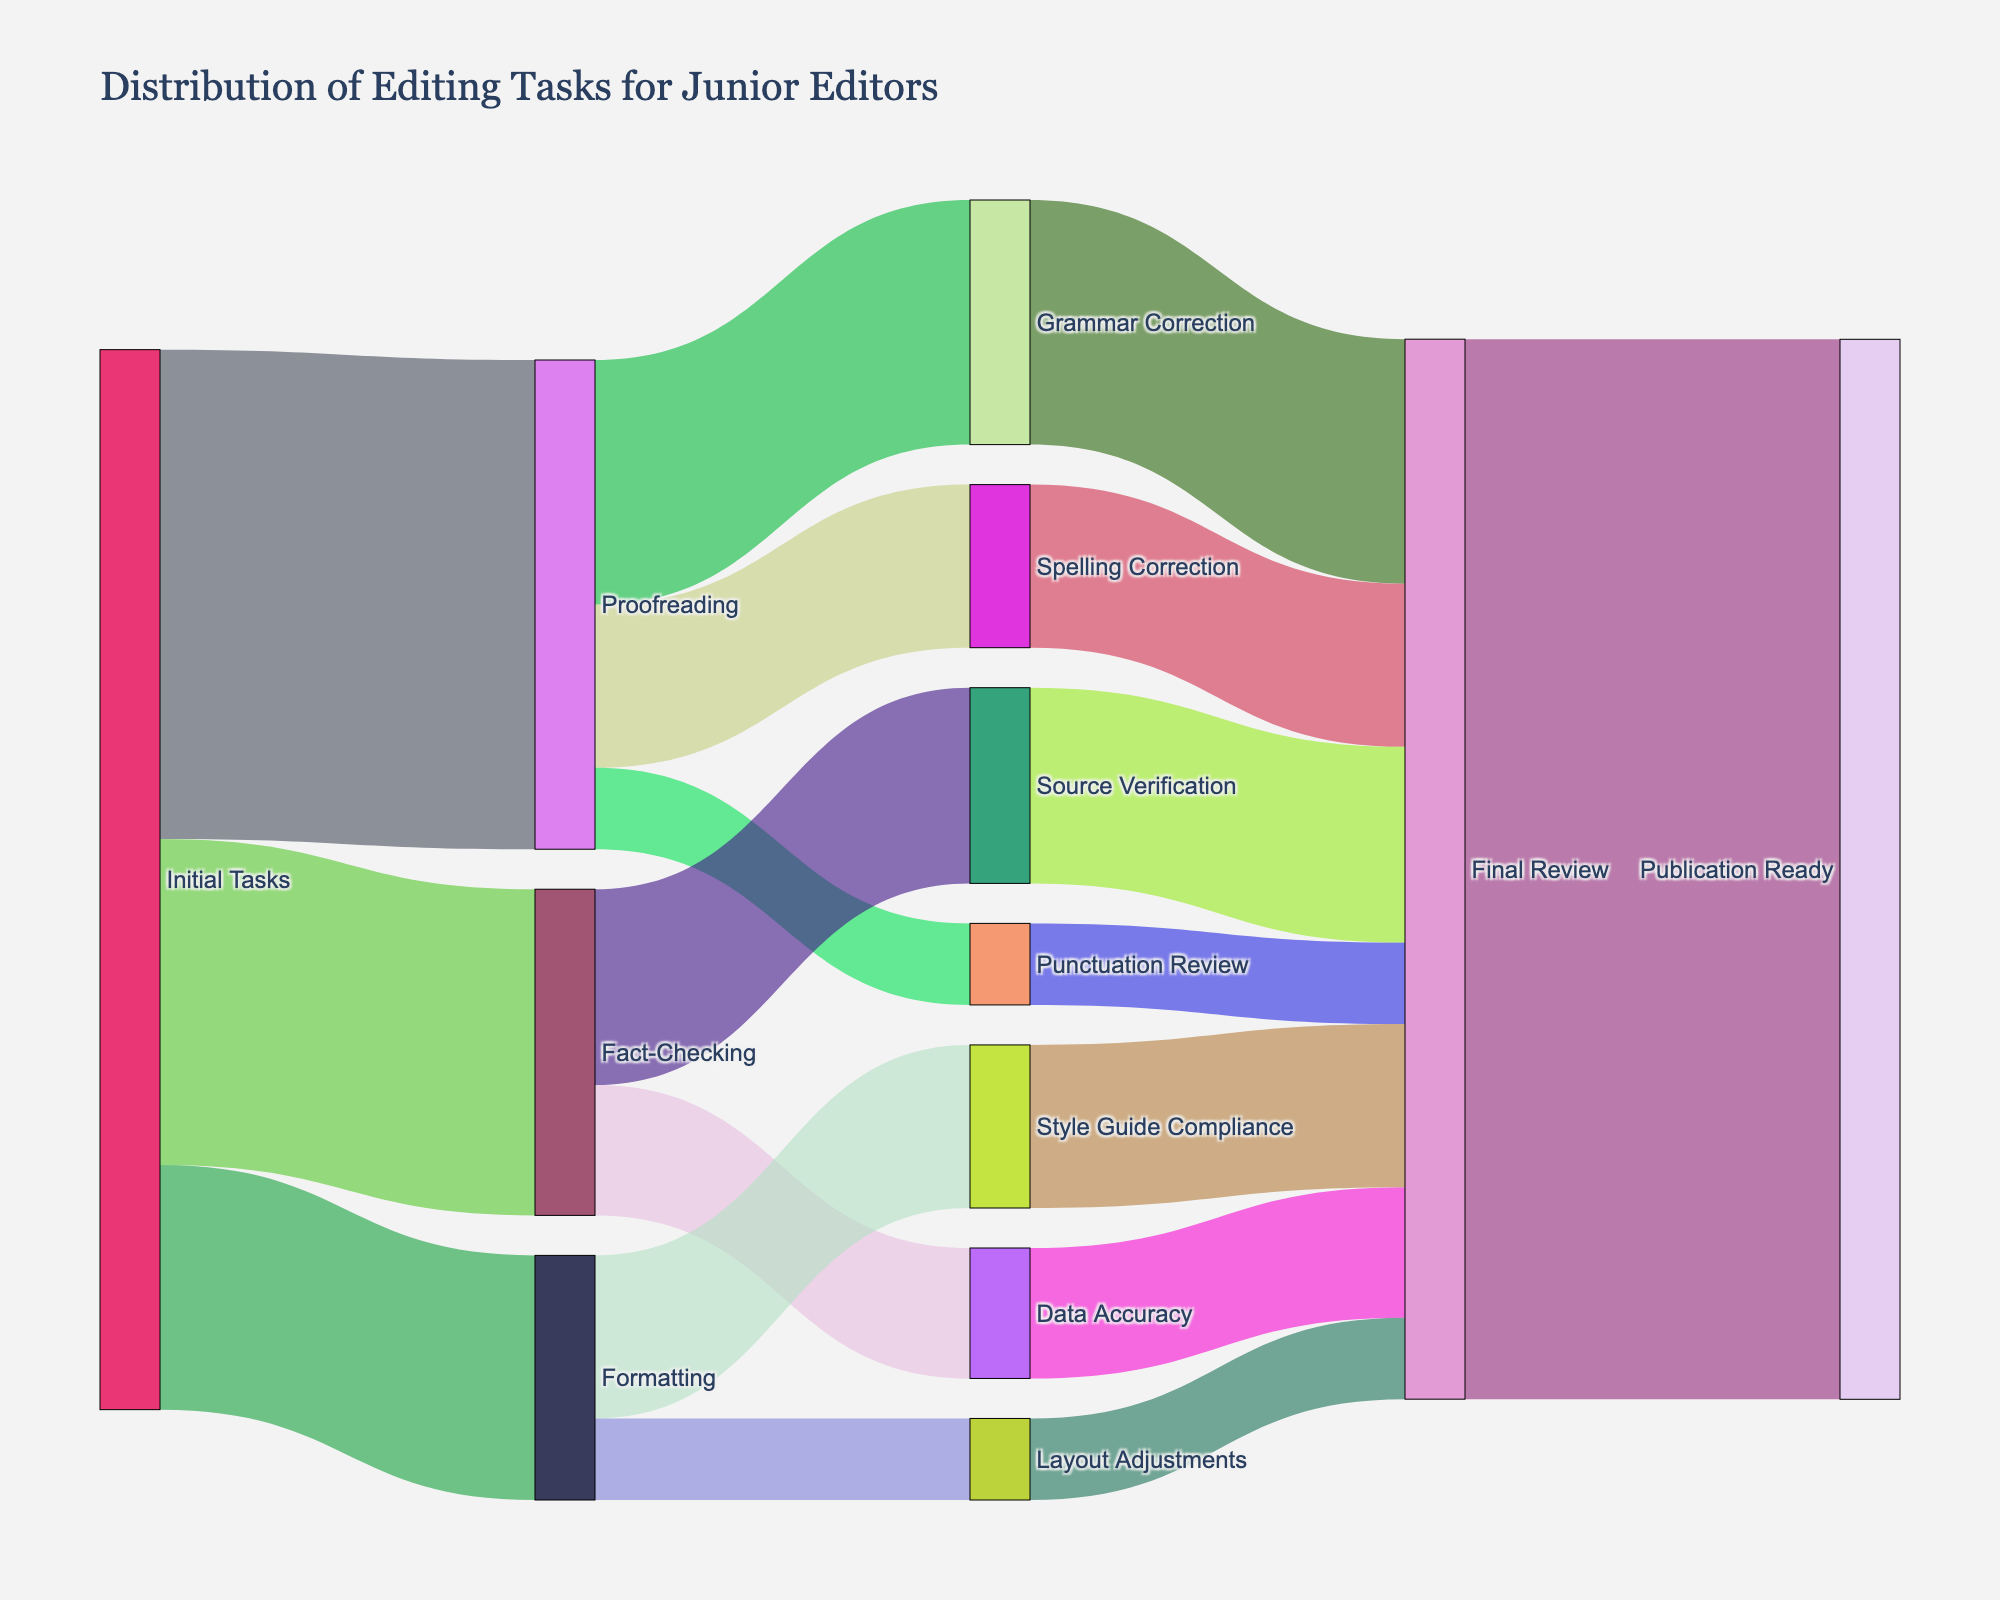What is the title of the Sankey diagram? The title can be found at the top of the diagram. It provides an immediate summary of what the diagram is illustrating.
Answer: Distribution of Editing Tasks for Junior Editors How many different types of initial tasks are there? Count the distinct types of tasks originating from the "Initial Tasks" node. These tasks are Proofreading, Fact-Checking, and Formatting.
Answer: 3 Which task shows the highest number of connections originating from Proofreading? Follow the links starting from Proofreading. Count their occurrences and identify the one with the largest value (Grammar Correction: 15, Spelling Correction: 10, Punctuation Review: 5).
Answer: Grammar Correction Which two subtasks of Fact-Checking have been performed? Identify the tasks directly connected to Fact-Checking (Source Verification and Data Accuracy). The subtasks are the nodes linking from Fact-Checking.
Answer: Source Verification and Data Accuracy What is the final destination for all the editing tasks? Trace the paths of all the flows until they reach the final node, which in this case is "Publication Ready."
Answer: Publication Ready How many tasks go to the Final Review node? Sum all the values of tasks flowing into the "Final Review" node. (e.g., Grammar Correction: 15, Spelling Correction: 10, Punctuation Review: 5, Source Verification: 12, Data Accuracy: 8, Style Guide Compliance: 10, Layout Adjustments: 5).
Answer: 65 What is the total number of tasks that originated from Fact-Checking? Add up the values for all connections originating from "Fact-Checking" (Source Verification: 12 and Data Accuracy: 8).
Answer: 20 How does the number of tasks involved in Grammar Correction compare to Spelling Correction? Compare the values of tasks from Proofreading that flow into Grammar Correction and Spelling Correction nodes. Grammar Correction has 15, while Spelling Correction has 10.
Answer: Grammar Correction has more Which process ensures there are most tasks in the "Final Review" stage? Identify the process that sends the highest number of tasks to the "Final Review" node. Trace the largest value originating to Final Review. (Grammar Correction: 15).
Answer: Grammar Correction What proportion of initial Proofreading tasks resulted in Grammar Correction? Divide the number of tasks from Proofreading to Grammar Correction by the total number of Proofreading tasks (Grammar Correction: 15 / Proofreading: 15 + 10 + 5 = 30).
Answer: 0.5 or 50% 